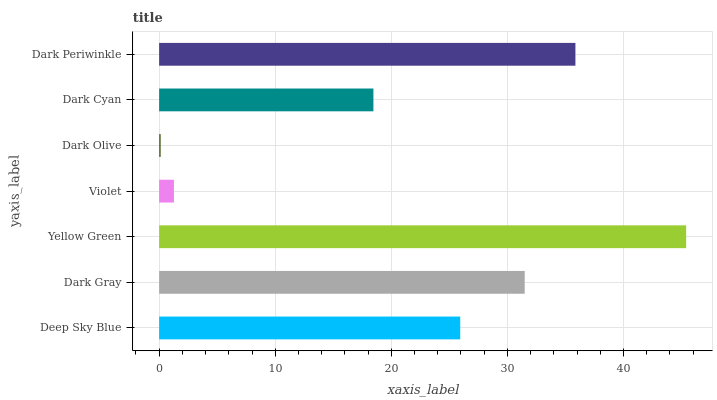Is Dark Olive the minimum?
Answer yes or no. Yes. Is Yellow Green the maximum?
Answer yes or no. Yes. Is Dark Gray the minimum?
Answer yes or no. No. Is Dark Gray the maximum?
Answer yes or no. No. Is Dark Gray greater than Deep Sky Blue?
Answer yes or no. Yes. Is Deep Sky Blue less than Dark Gray?
Answer yes or no. Yes. Is Deep Sky Blue greater than Dark Gray?
Answer yes or no. No. Is Dark Gray less than Deep Sky Blue?
Answer yes or no. No. Is Deep Sky Blue the high median?
Answer yes or no. Yes. Is Deep Sky Blue the low median?
Answer yes or no. Yes. Is Dark Olive the high median?
Answer yes or no. No. Is Dark Gray the low median?
Answer yes or no. No. 